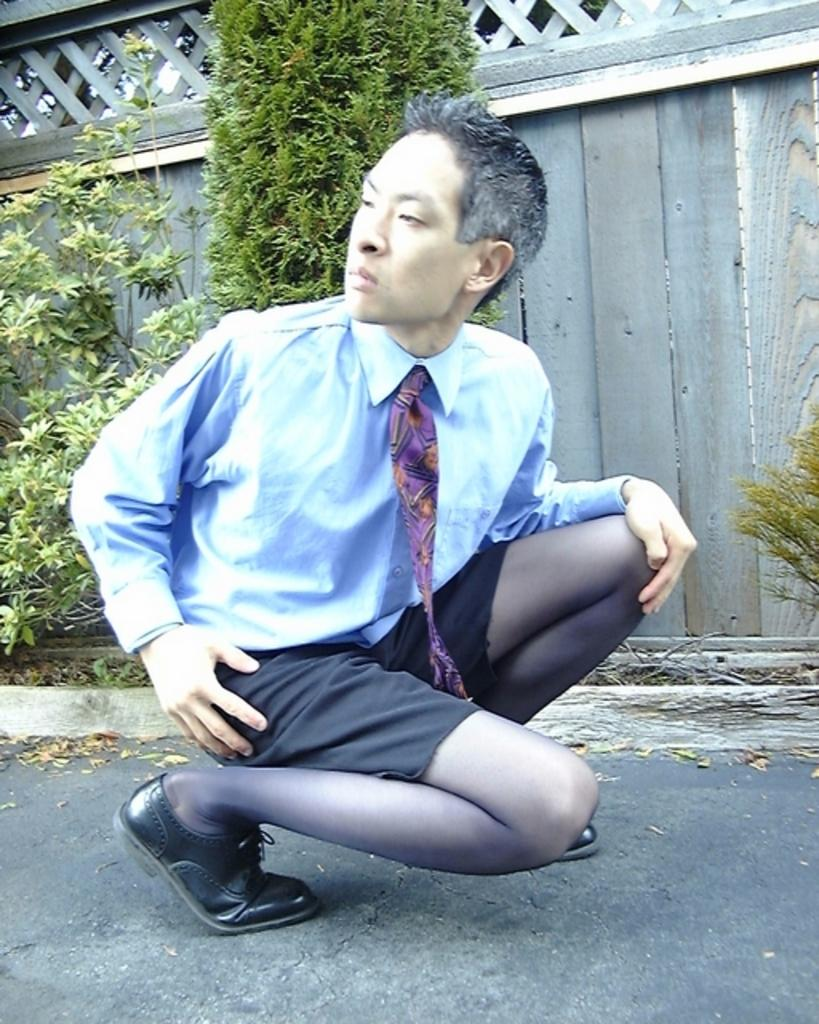Who is present in the image? There is a person in the image. What is the person wearing on their upper body? The person is wearing a white shirt. What is the person wearing on their lower body? The person is wearing black shorts. What can be seen in the background of the image? There is a house and trees with green color in the background of the image. How many fingers are visible on the person's hand in the image? The image does not show the person's hand, so it is not possible to determine how many fingers are visible. 